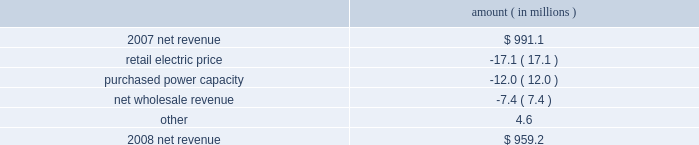Entergy louisiana , llc management's financial discussion and analysis net revenue 2008 compared to 2007 net revenue consists of operating revenues net of : 1 ) fuel , fuel-related expenses , and gas purchased for resale , 2 ) purchased power expenses , and 3 ) other regulatory charges .
Following is an analysis of the change in net revenue comparing 2008 to 2007 .
Amount ( in millions ) .
The retail electric price variance is primarily due to the cessation of the interim storm recovery through the formula rate plan upon the act 55 financing of storm costs and a credit passed on to customers as a result of the act 55 storm cost financing , partially offset by increases in the formula rate plan effective october 2007 .
Refer to "hurricane rita and hurricane katrina" and "state and local rate regulation" below for a discussion of the interim recovery of storm costs , the act 55 storm cost financing , and the formula rate plan filing .
The purchased power capacity variance is due to the amortization of deferred capacity costs effective september 2007 as a result of the formula rate plan filing in may 2007 .
Purchased power capacity costs are offset in base revenues due to a base rate increase implemented to recover incremental deferred and ongoing purchased power capacity charges .
See "state and local rate regulation" below for a discussion of the formula rate plan filing .
The net wholesale revenue variance is primarily due to provisions recorded for potential rate refunds related to the treatment of interruptible load in pricing entergy system affiliate sales .
Gross operating revenue and , fuel and purchased power expenses gross operating revenues increased primarily due to an increase of $ 364.7 million in fuel cost recovery revenues due to higher fuel rates offset by decreased usage .
The increase was partially offset by a decrease of $ 56.8 million in gross wholesale revenue due to a decrease in system agreement rough production cost equalization credits .
Fuel and purchased power expenses increased primarily due to increases in the average market prices of natural gas and purchased power , partially offset by a decrease in the recovery from customers of deferred fuel costs. .
What percent of the change in net revenue between 2007 and 2008 was due to purchased power capacity? 
Computations: (-12.0 / (959.2 - 991.1))
Answer: 0.37618. 